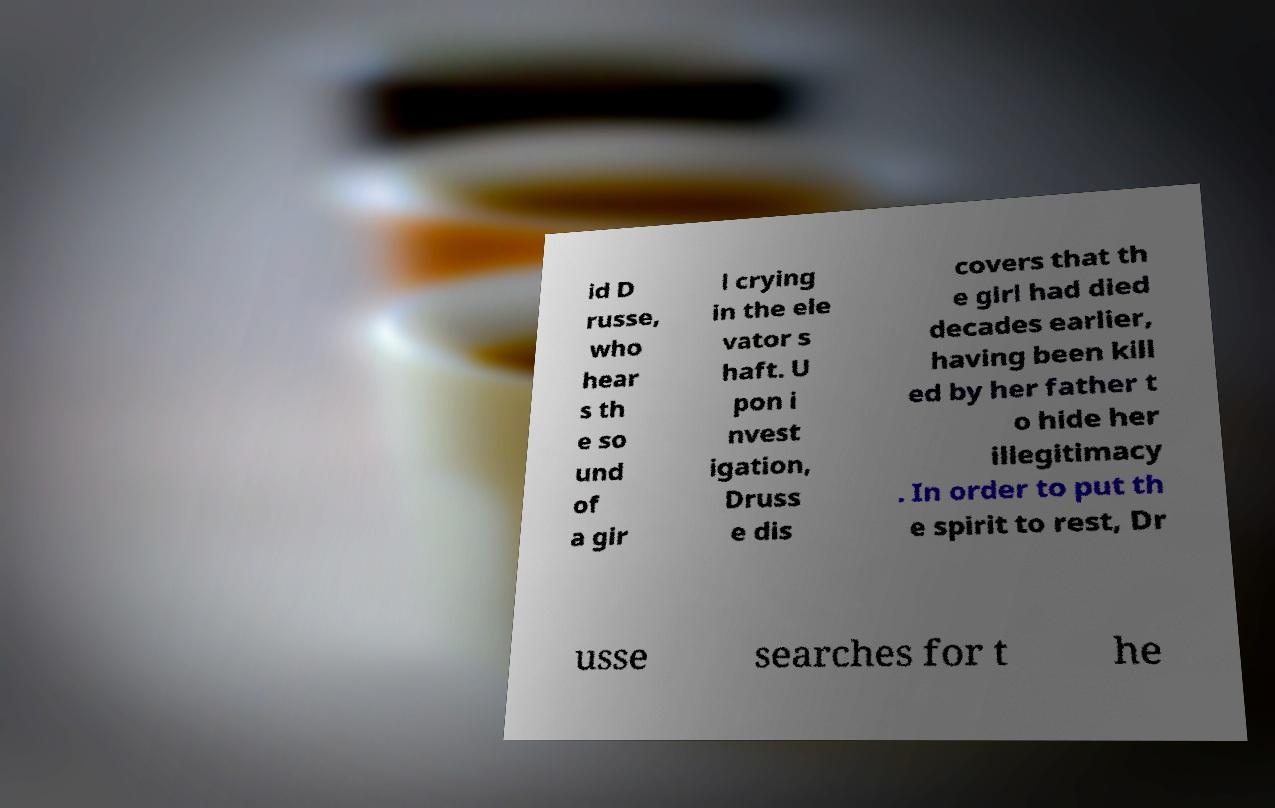Can you read and provide the text displayed in the image?This photo seems to have some interesting text. Can you extract and type it out for me? id D russe, who hear s th e so und of a gir l crying in the ele vator s haft. U pon i nvest igation, Druss e dis covers that th e girl had died decades earlier, having been kill ed by her father t o hide her illegitimacy . In order to put th e spirit to rest, Dr usse searches for t he 